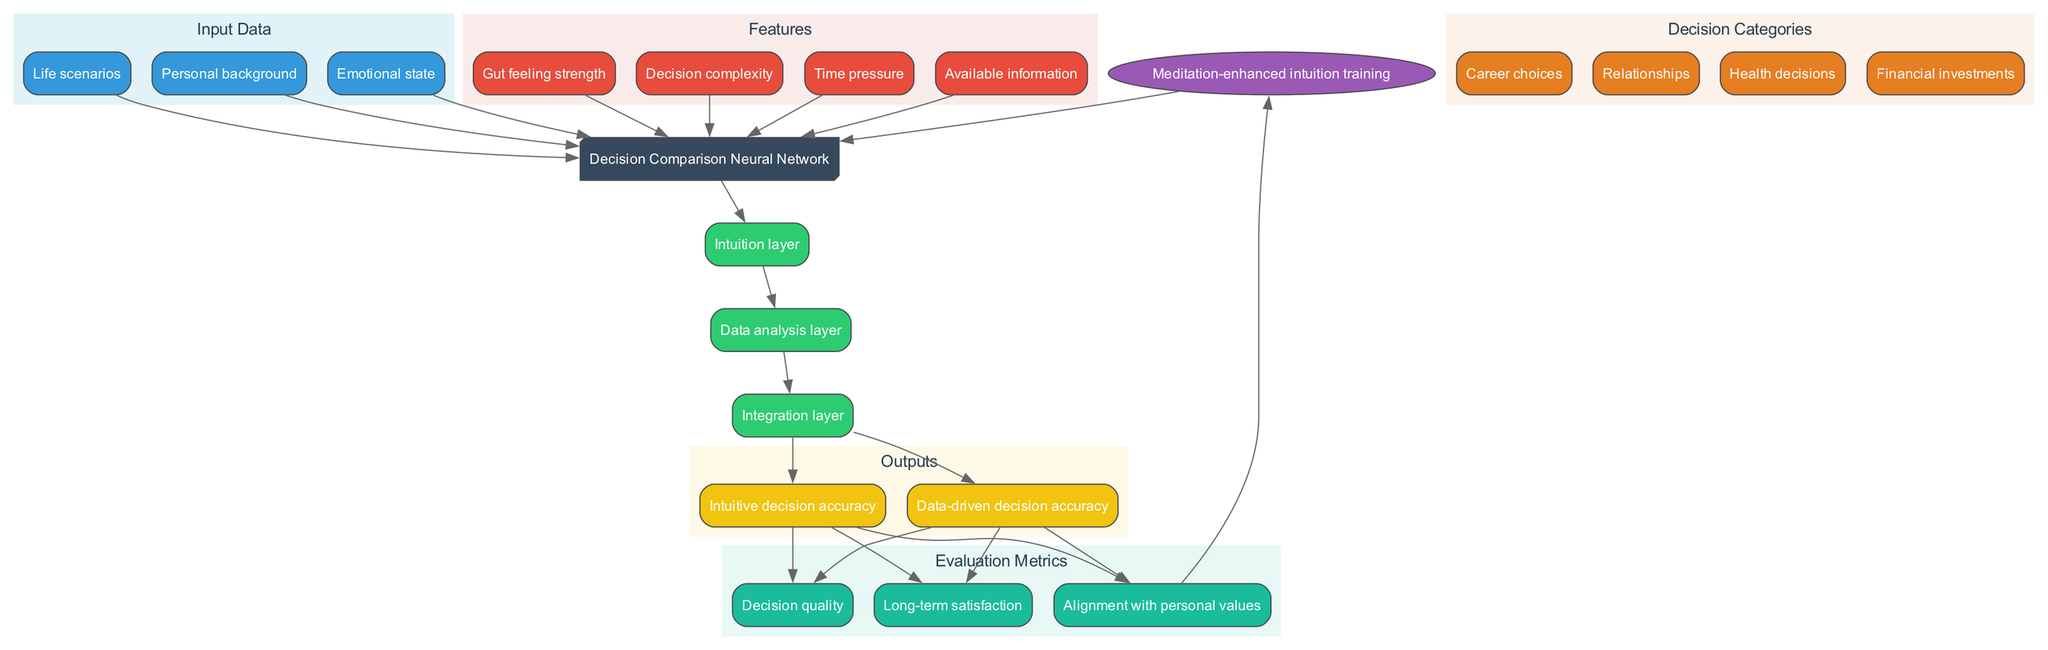What are the inputs to the model? The inputs to the model are listed directly in the 'Input Data' cluster, which includes "Life scenarios," "Personal background," and "Emotional state."
Answer: Life scenarios, Personal background, Emotional state How many layers are present in the model? The model comprises three layers as illustrated in the 'Layers' section. These layers are "Intuition layer," "Data analysis layer," and "Integration layer."
Answer: 3 What is the final output of the model? The output is defined in the 'Outputs' section, which includes two items: "Intuitive decision accuracy" and "Data-driven decision accuracy."
Answer: Intuitive decision accuracy, Data-driven decision accuracy Which feedback loop is used in the diagram? In the diagram, the feedback loop is specified as "Meditation-enhanced intuition training," which is indicated in a unique node.
Answer: Meditation-enhanced intuition training Which evaluation metric is related to aligning with personal values? The relevant evaluation metric indicated in the 'Evaluation Metrics' section is "Alignment with personal values."
Answer: Alignment with personal values What type of decisions are evaluated in this diagram? The types of decisions evaluated are categorized under 'Decision Categories,' which feature "Career choices," "Relationships," "Health decisions," and "Financial investments."
Answer: Career choices, Relationships, Health decisions, Financial investments If the decision complexity is high, what output is likely to have a lower accuracy? Since high decision complexity may negatively impact the decision-making process, it is reasonable to conclude that "Intuitive decision accuracy" is likely to be lower when complexity increases, as intuition typically favors simpler scenarios.
Answer: Intuitive decision accuracy How does the feedback loop affect the model? The feedback loop, "Meditation-enhanced intuition training," is connected to the model and serves to improve decision-making by enhancing intuition over iterations of the model's output, indicated by the edge linking the feedback to the model.
Answer: It improves decision-making 